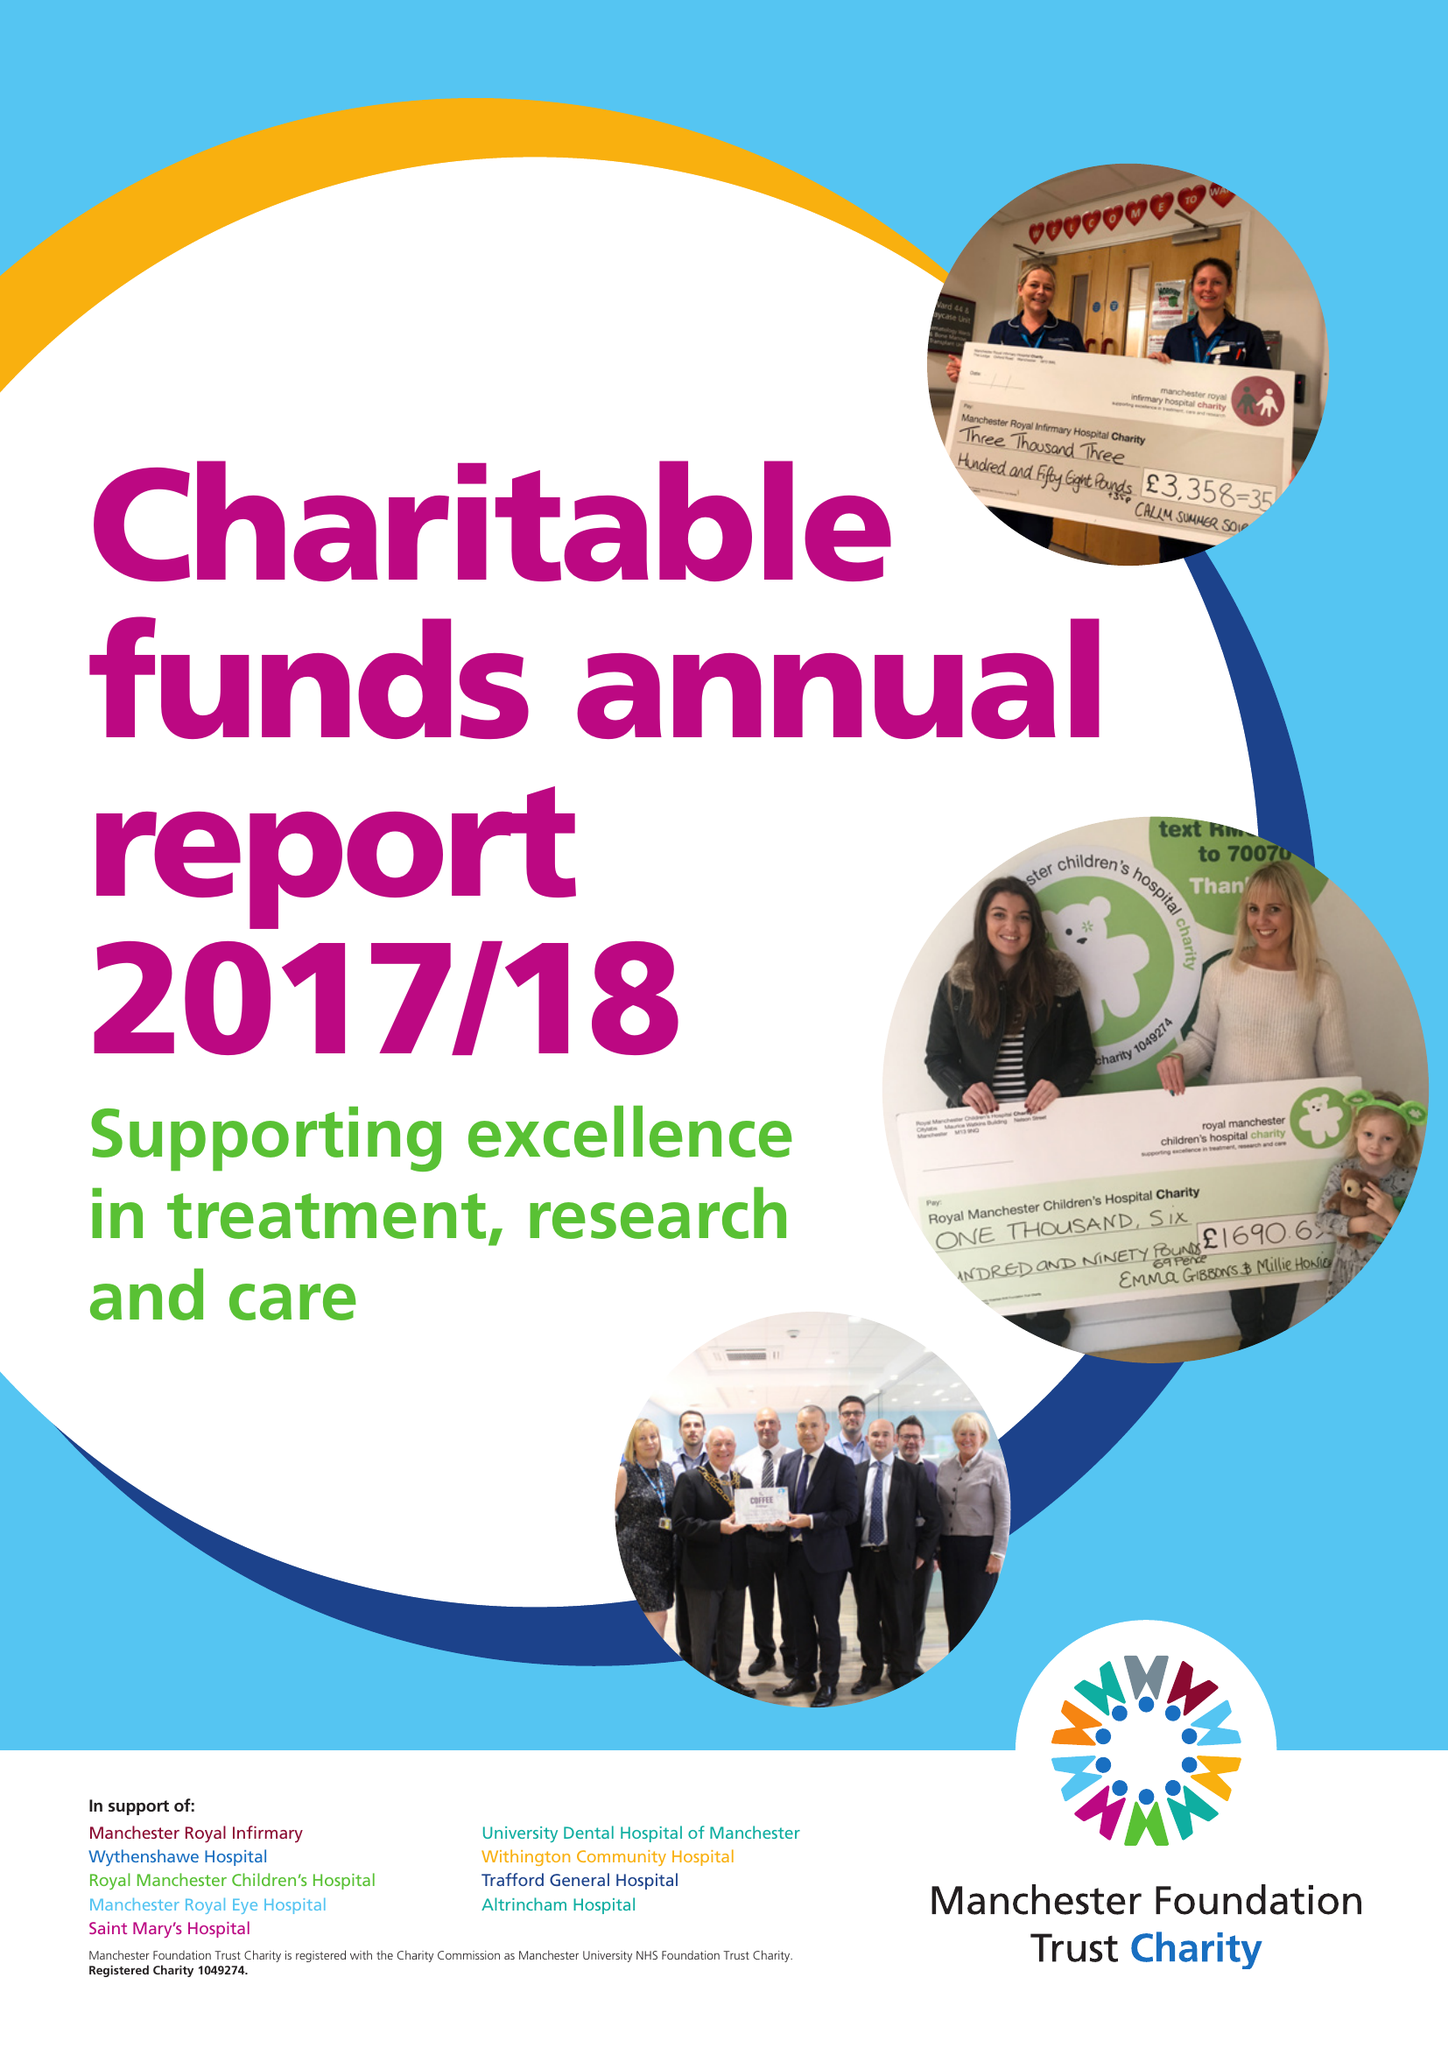What is the value for the address__postcode?
Answer the question using a single word or phrase. M13 9NQ 